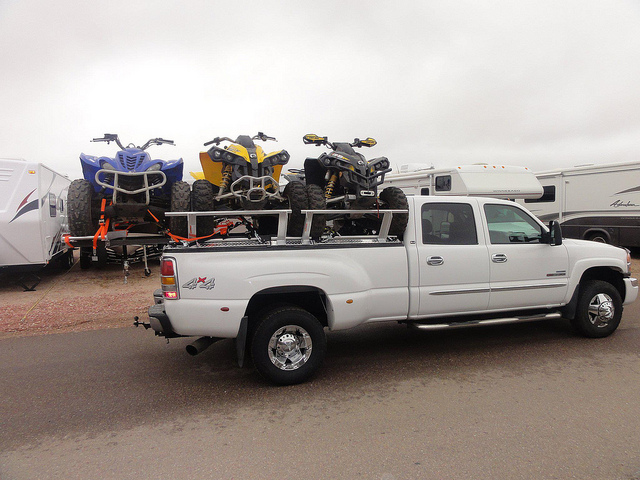Identify the text displayed in this image. 4X4 